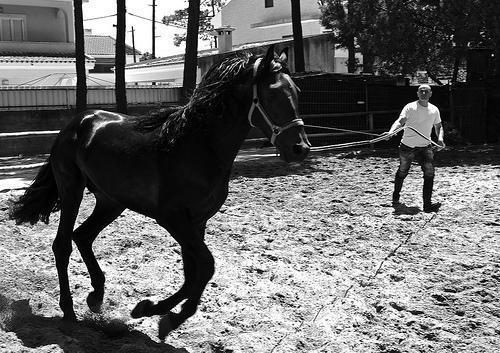How many animals are shown?
Give a very brief answer. 1. 